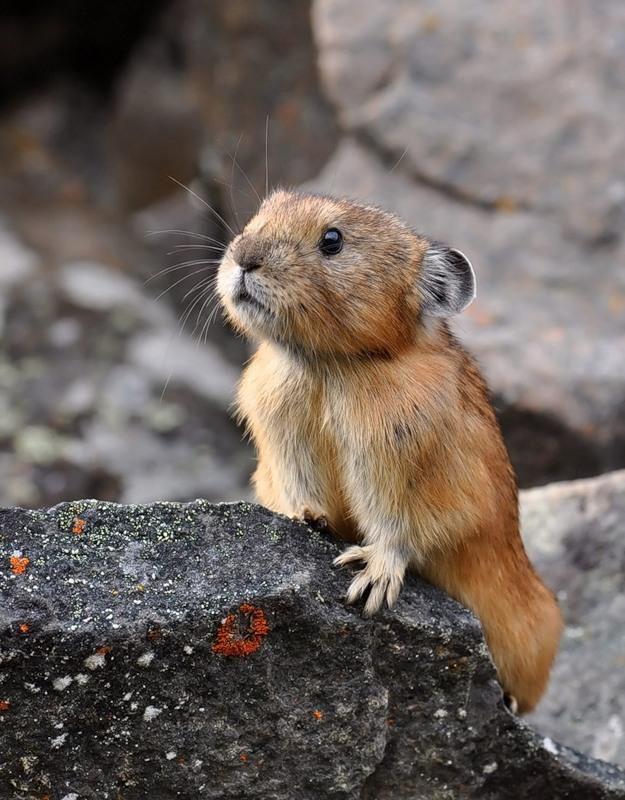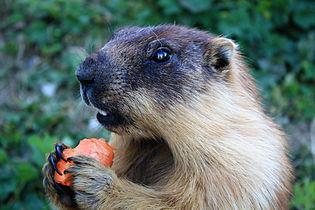The first image is the image on the left, the second image is the image on the right. Analyze the images presented: Is the assertion "An image shows only one marmot, which is on all fours with body and head facing right." valid? Answer yes or no. No. The first image is the image on the left, the second image is the image on the right. For the images shown, is this caption "The animal in the left image is standing on a boulder." true? Answer yes or no. Yes. 